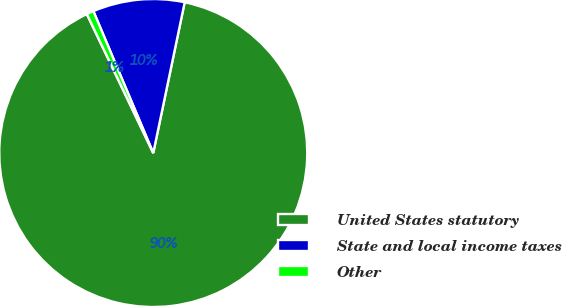Convert chart to OTSL. <chart><loc_0><loc_0><loc_500><loc_500><pie_chart><fcel>United States statutory<fcel>State and local income taxes<fcel>Other<nl><fcel>89.63%<fcel>9.63%<fcel>0.74%<nl></chart> 